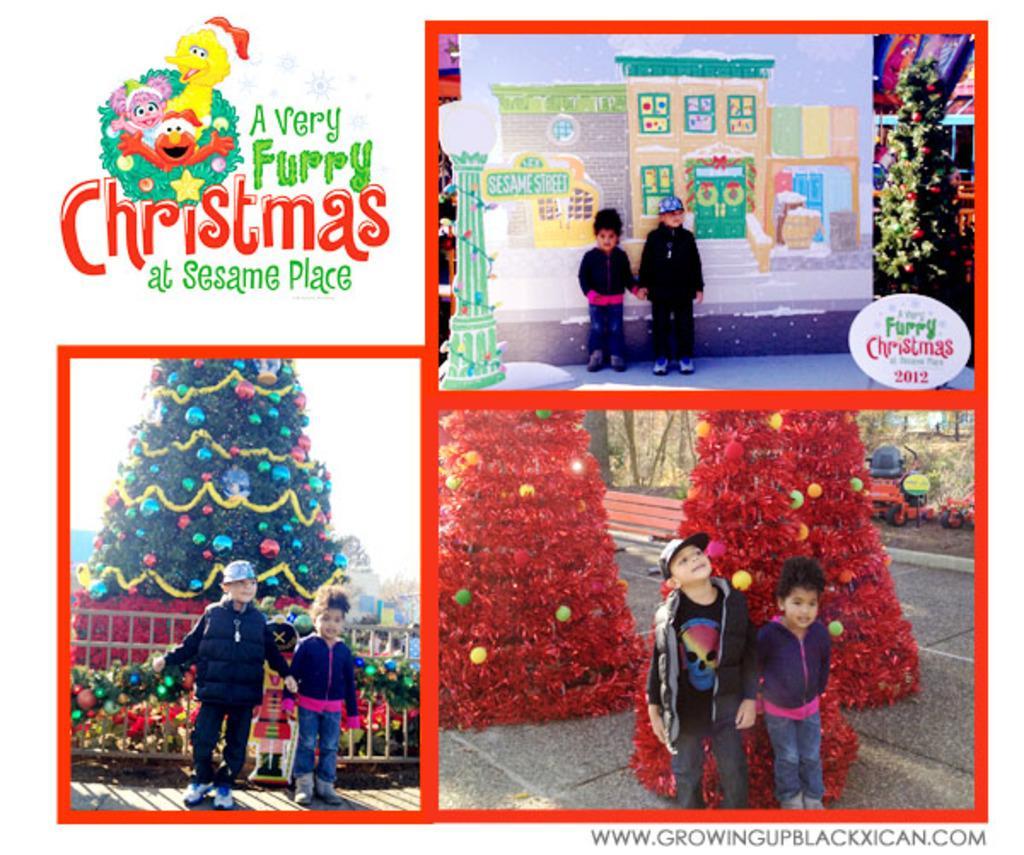How would you summarize this image in a sentence or two? In the picture I can see collage image, two children are taking pictures in different places and the are few words written. 